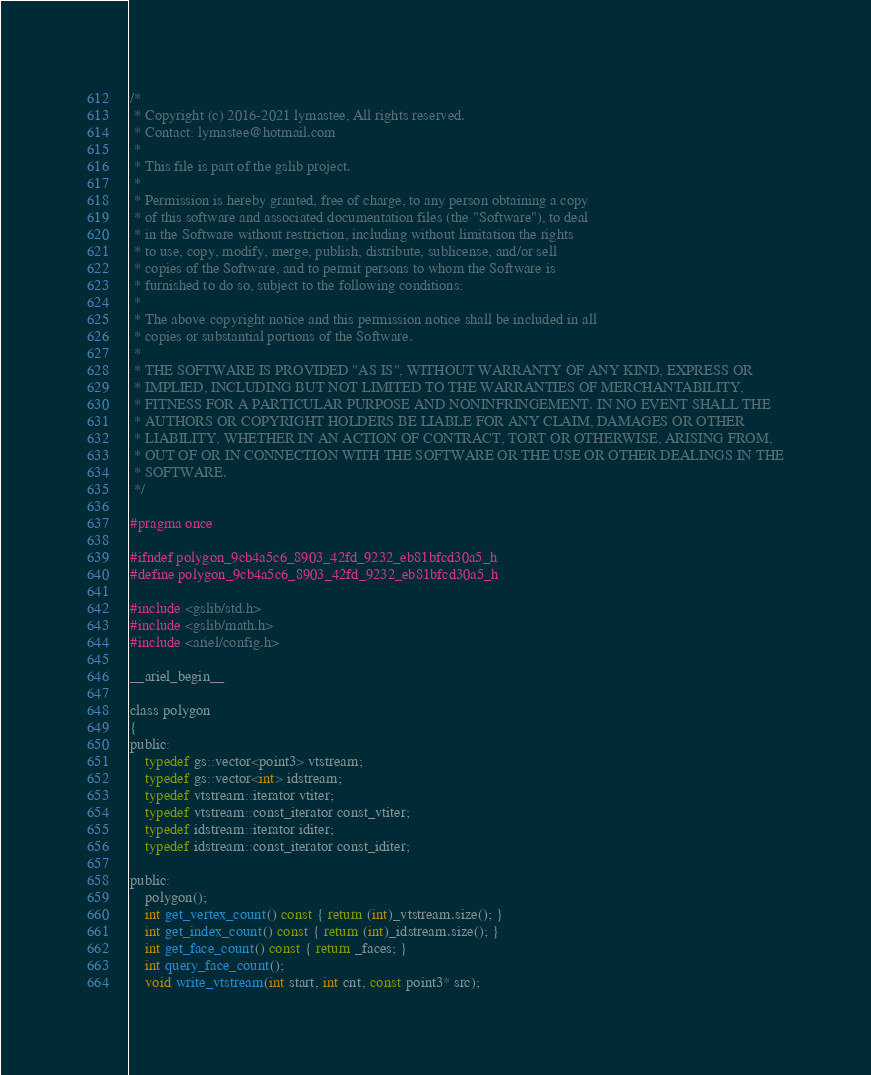<code> <loc_0><loc_0><loc_500><loc_500><_C_>/*
 * Copyright (c) 2016-2021 lymastee, All rights reserved.
 * Contact: lymastee@hotmail.com
 *
 * This file is part of the gslib project.
 * 
 * Permission is hereby granted, free of charge, to any person obtaining a copy
 * of this software and associated documentation files (the "Software"), to deal
 * in the Software without restriction, including without limitation the rights
 * to use, copy, modify, merge, publish, distribute, sublicense, and/or sell
 * copies of the Software, and to permit persons to whom the Software is
 * furnished to do so, subject to the following conditions:
 * 
 * The above copyright notice and this permission notice shall be included in all
 * copies or substantial portions of the Software.
 * 
 * THE SOFTWARE IS PROVIDED "AS IS", WITHOUT WARRANTY OF ANY KIND, EXPRESS OR
 * IMPLIED, INCLUDING BUT NOT LIMITED TO THE WARRANTIES OF MERCHANTABILITY,
 * FITNESS FOR A PARTICULAR PURPOSE AND NONINFRINGEMENT. IN NO EVENT SHALL THE
 * AUTHORS OR COPYRIGHT HOLDERS BE LIABLE FOR ANY CLAIM, DAMAGES OR OTHER
 * LIABILITY, WHETHER IN AN ACTION OF CONTRACT, TORT OR OTHERWISE, ARISING FROM,
 * OUT OF OR IN CONNECTION WITH THE SOFTWARE OR THE USE OR OTHER DEALINGS IN THE
 * SOFTWARE.
 */

#pragma once

#ifndef polygon_9cb4a5c6_8903_42fd_9232_eb81bfcd30a5_h
#define polygon_9cb4a5c6_8903_42fd_9232_eb81bfcd30a5_h

#include <gslib/std.h>
#include <gslib/math.h>
#include <ariel/config.h>

__ariel_begin__

class polygon
{
public:
    typedef gs::vector<point3> vtstream;
    typedef gs::vector<int> idstream;
    typedef vtstream::iterator vtiter;
    typedef vtstream::const_iterator const_vtiter;
    typedef idstream::iterator iditer;
    typedef idstream::const_iterator const_iditer;

public:
    polygon();
    int get_vertex_count() const { return (int)_vtstream.size(); }
    int get_index_count() const { return (int)_idstream.size(); }
    int get_face_count() const { return _faces; }
    int query_face_count();
    void write_vtstream(int start, int cnt, const point3* src);</code> 